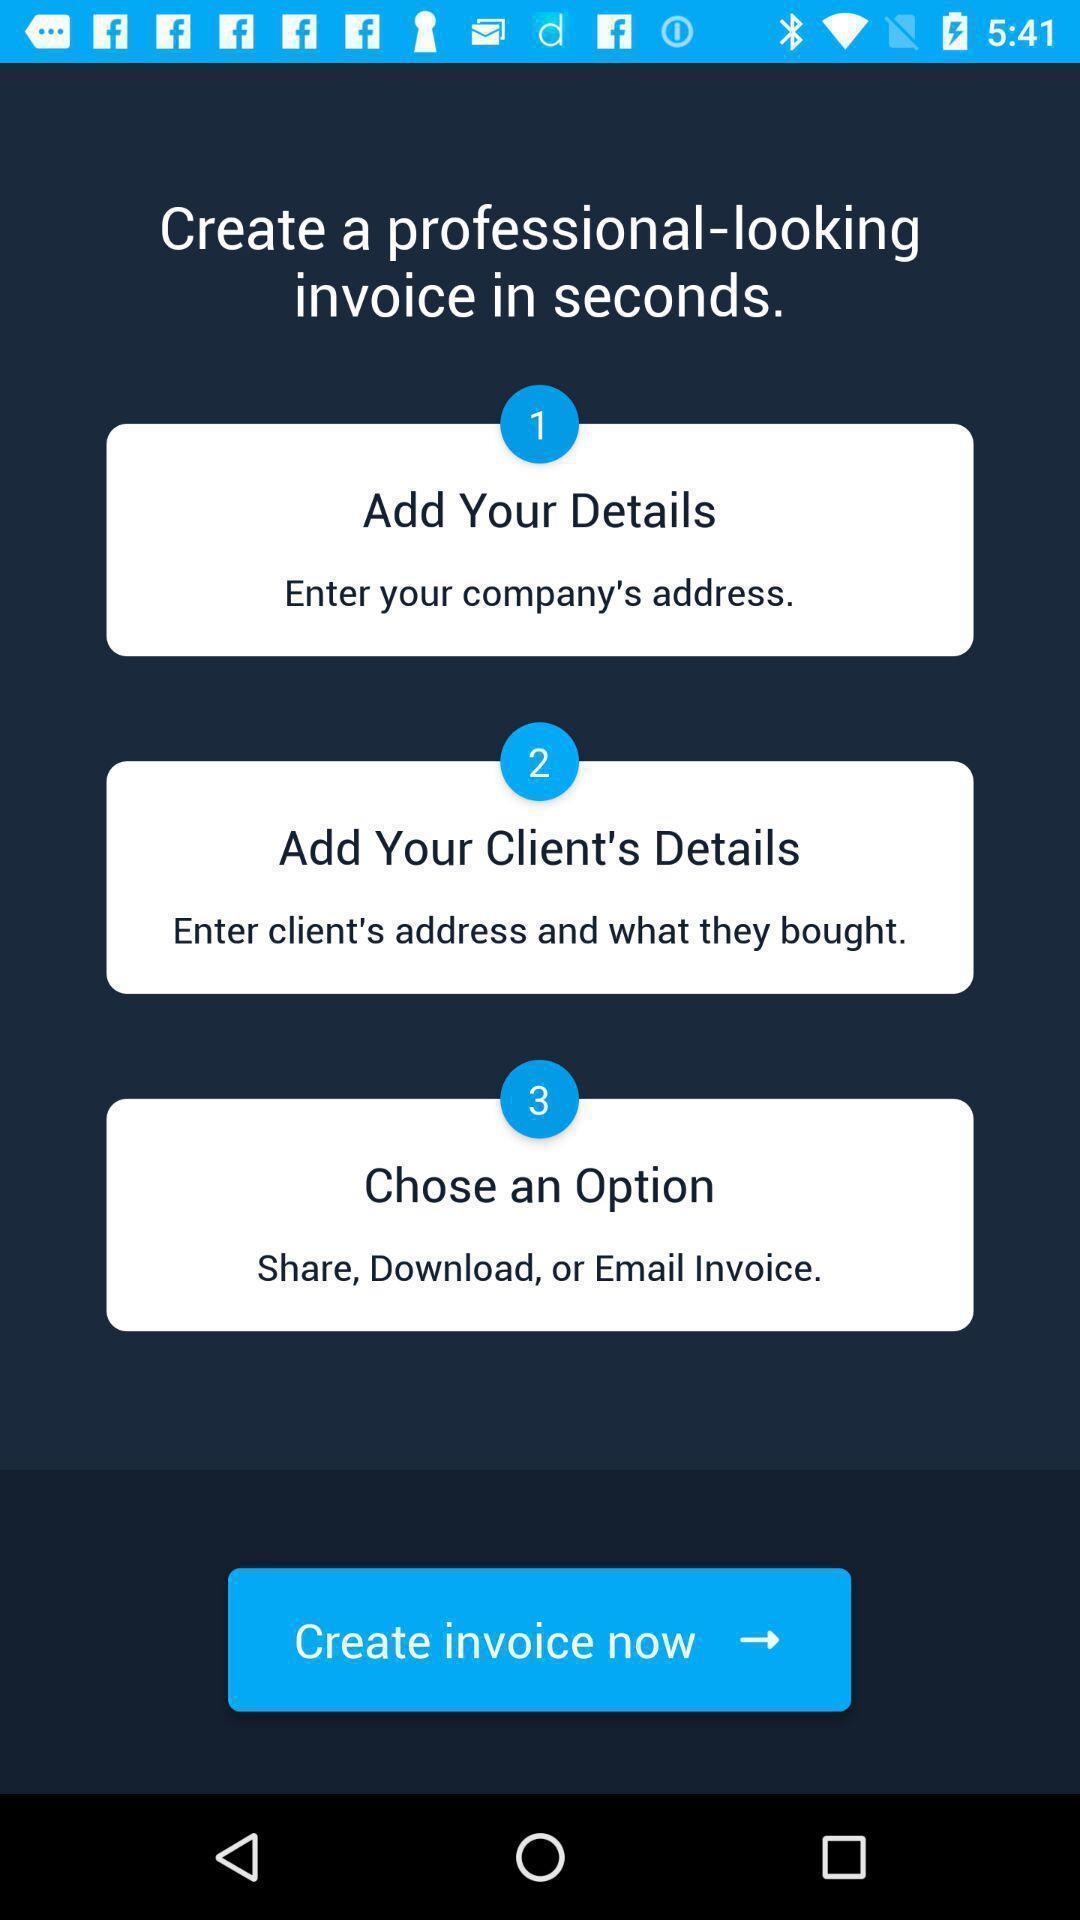Provide a textual representation of this image. Steps to add invoice details are displaying. 